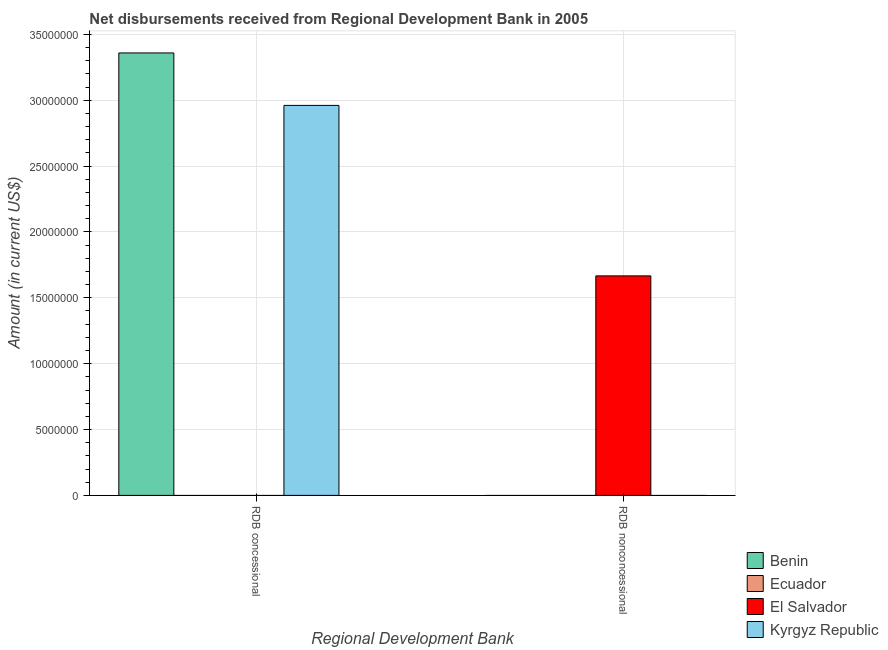How many bars are there on the 2nd tick from the right?
Your answer should be very brief. 2. What is the label of the 1st group of bars from the left?
Ensure brevity in your answer.  RDB concessional. Across all countries, what is the maximum net non concessional disbursements from rdb?
Your response must be concise. 1.67e+07. In which country was the net non concessional disbursements from rdb maximum?
Your answer should be compact. El Salvador. What is the total net non concessional disbursements from rdb in the graph?
Offer a very short reply. 1.67e+07. What is the difference between the net concessional disbursements from rdb in Benin and that in Kyrgyz Republic?
Provide a succinct answer. 3.98e+06. What is the average net concessional disbursements from rdb per country?
Keep it short and to the point. 1.58e+07. Is the net concessional disbursements from rdb in Kyrgyz Republic less than that in Benin?
Your answer should be very brief. Yes. How many bars are there?
Ensure brevity in your answer.  3. Are all the bars in the graph horizontal?
Your answer should be very brief. No. How many countries are there in the graph?
Offer a terse response. 4. Are the values on the major ticks of Y-axis written in scientific E-notation?
Offer a very short reply. No. Does the graph contain any zero values?
Offer a terse response. Yes. How many legend labels are there?
Give a very brief answer. 4. How are the legend labels stacked?
Make the answer very short. Vertical. What is the title of the graph?
Provide a short and direct response. Net disbursements received from Regional Development Bank in 2005. What is the label or title of the X-axis?
Ensure brevity in your answer.  Regional Development Bank. What is the label or title of the Y-axis?
Your answer should be compact. Amount (in current US$). What is the Amount (in current US$) of Benin in RDB concessional?
Offer a very short reply. 3.36e+07. What is the Amount (in current US$) in Ecuador in RDB concessional?
Provide a succinct answer. 0. What is the Amount (in current US$) of El Salvador in RDB concessional?
Your response must be concise. 0. What is the Amount (in current US$) in Kyrgyz Republic in RDB concessional?
Provide a short and direct response. 2.96e+07. What is the Amount (in current US$) in El Salvador in RDB nonconcessional?
Provide a succinct answer. 1.67e+07. Across all Regional Development Bank, what is the maximum Amount (in current US$) in Benin?
Give a very brief answer. 3.36e+07. Across all Regional Development Bank, what is the maximum Amount (in current US$) in El Salvador?
Your answer should be compact. 1.67e+07. Across all Regional Development Bank, what is the maximum Amount (in current US$) of Kyrgyz Republic?
Offer a terse response. 2.96e+07. Across all Regional Development Bank, what is the minimum Amount (in current US$) of El Salvador?
Your answer should be compact. 0. What is the total Amount (in current US$) of Benin in the graph?
Keep it short and to the point. 3.36e+07. What is the total Amount (in current US$) in Ecuador in the graph?
Offer a terse response. 0. What is the total Amount (in current US$) in El Salvador in the graph?
Your answer should be compact. 1.67e+07. What is the total Amount (in current US$) of Kyrgyz Republic in the graph?
Offer a very short reply. 2.96e+07. What is the difference between the Amount (in current US$) of Benin in RDB concessional and the Amount (in current US$) of El Salvador in RDB nonconcessional?
Offer a terse response. 1.69e+07. What is the average Amount (in current US$) of Benin per Regional Development Bank?
Your answer should be very brief. 1.68e+07. What is the average Amount (in current US$) in Ecuador per Regional Development Bank?
Ensure brevity in your answer.  0. What is the average Amount (in current US$) in El Salvador per Regional Development Bank?
Provide a succinct answer. 8.33e+06. What is the average Amount (in current US$) in Kyrgyz Republic per Regional Development Bank?
Your answer should be compact. 1.48e+07. What is the difference between the Amount (in current US$) of Benin and Amount (in current US$) of Kyrgyz Republic in RDB concessional?
Your answer should be compact. 3.98e+06. What is the difference between the highest and the lowest Amount (in current US$) in Benin?
Offer a very short reply. 3.36e+07. What is the difference between the highest and the lowest Amount (in current US$) of El Salvador?
Your response must be concise. 1.67e+07. What is the difference between the highest and the lowest Amount (in current US$) in Kyrgyz Republic?
Keep it short and to the point. 2.96e+07. 